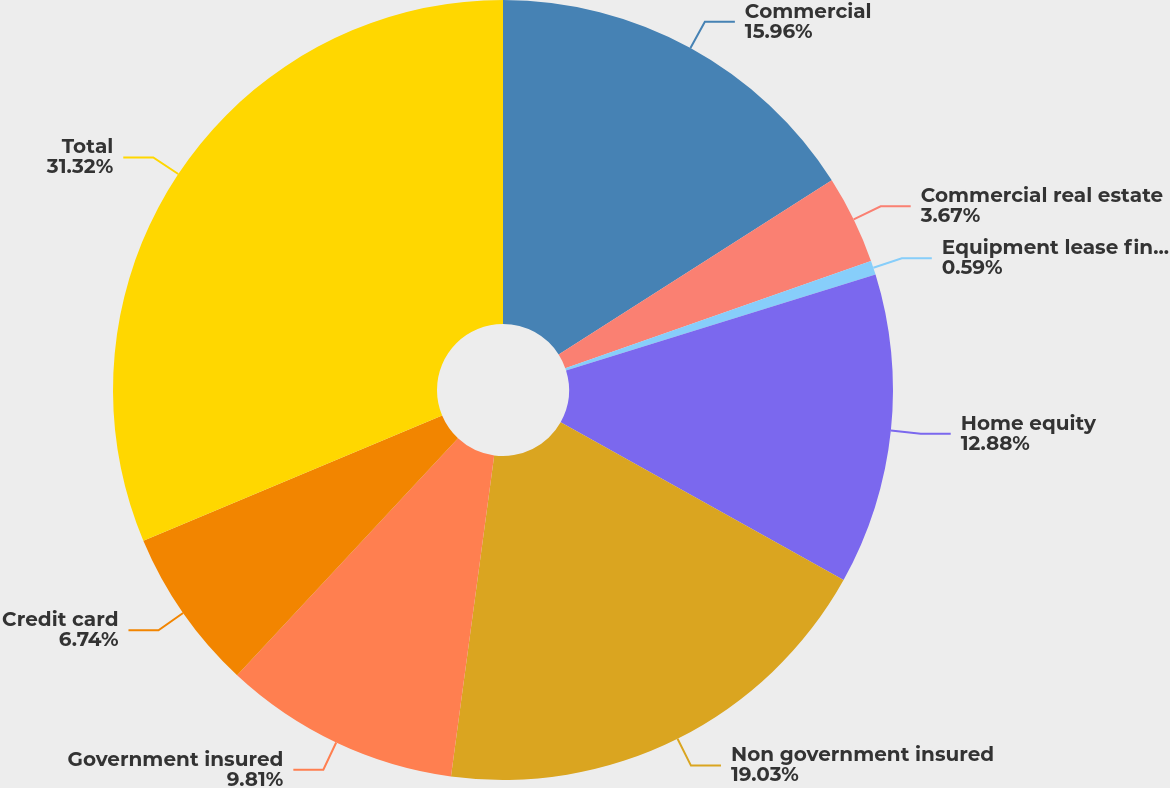<chart> <loc_0><loc_0><loc_500><loc_500><pie_chart><fcel>Commercial<fcel>Commercial real estate<fcel>Equipment lease financing<fcel>Home equity<fcel>Non government insured<fcel>Government insured<fcel>Credit card<fcel>Total<nl><fcel>15.96%<fcel>3.67%<fcel>0.59%<fcel>12.88%<fcel>19.03%<fcel>9.81%<fcel>6.74%<fcel>31.32%<nl></chart> 